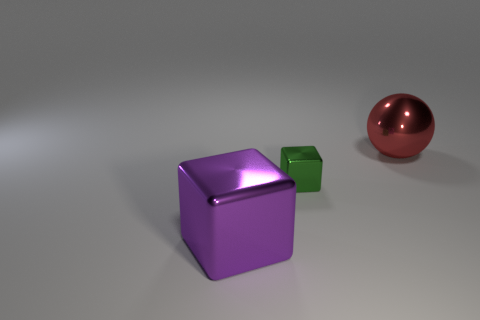What is the color of the big object that is behind the purple thing? red 